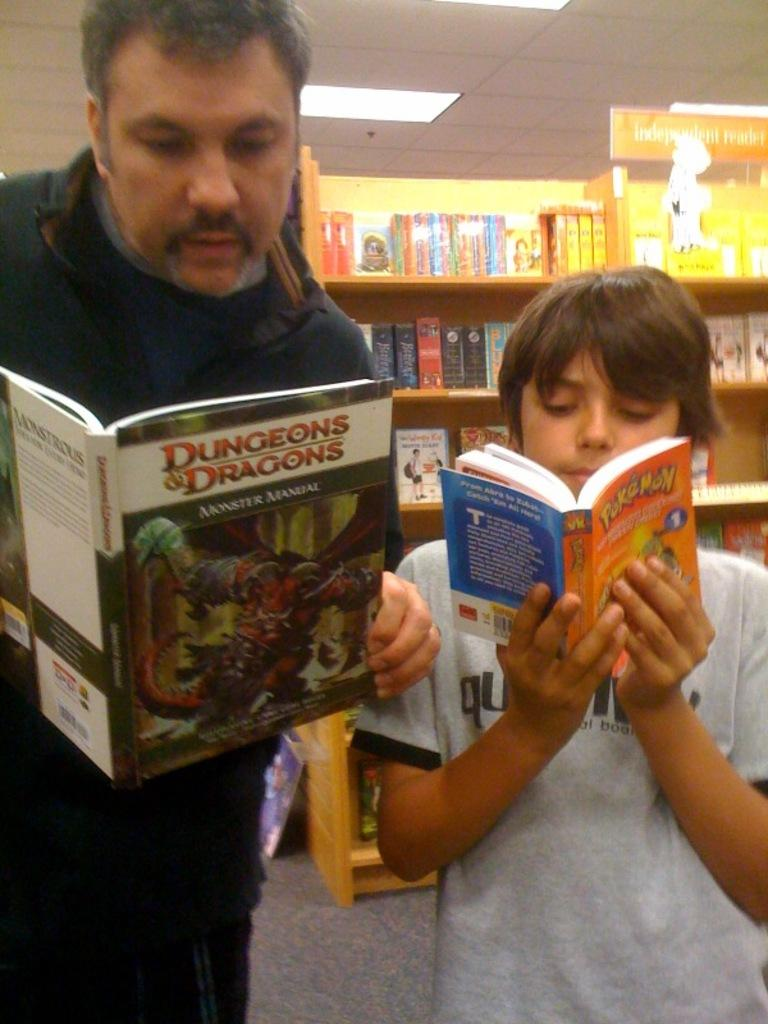<image>
Render a clear and concise summary of the photo. An older man and a young boy reading Dungeons and Dragons and Pokemon. 